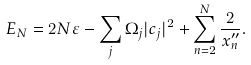Convert formula to latex. <formula><loc_0><loc_0><loc_500><loc_500>E _ { N } = 2 N \varepsilon - \sum _ { j } \Omega _ { j } | c _ { j } | ^ { 2 } + \sum _ { n = 2 } ^ { N } \frac { 2 } { x _ { n } ^ { \prime \prime } } .</formula> 